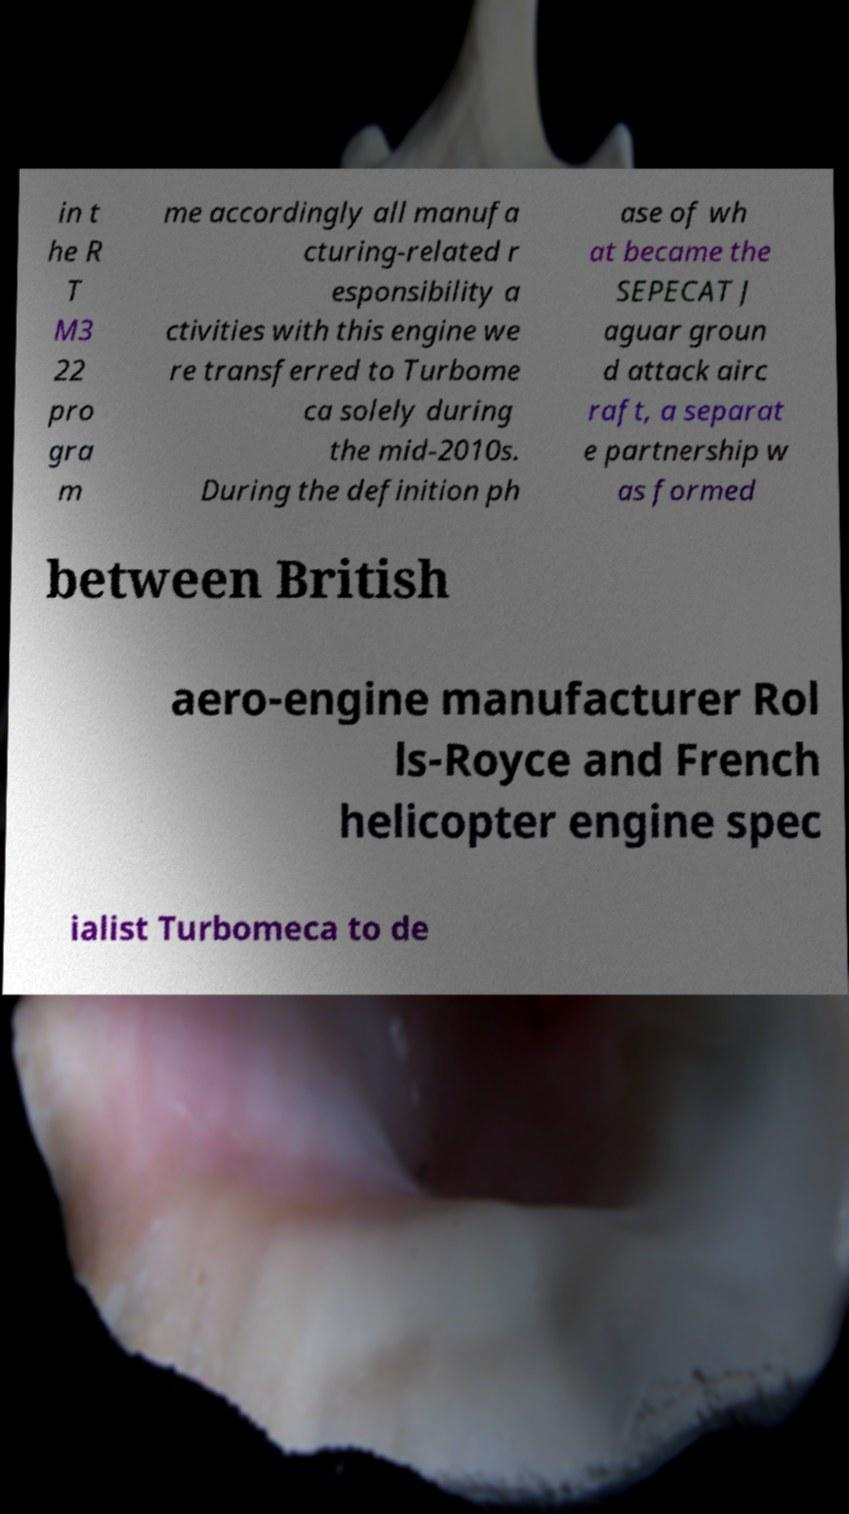What messages or text are displayed in this image? I need them in a readable, typed format. in t he R T M3 22 pro gra m me accordingly all manufa cturing-related r esponsibility a ctivities with this engine we re transferred to Turbome ca solely during the mid-2010s. During the definition ph ase of wh at became the SEPECAT J aguar groun d attack airc raft, a separat e partnership w as formed between British aero-engine manufacturer Rol ls-Royce and French helicopter engine spec ialist Turbomeca to de 